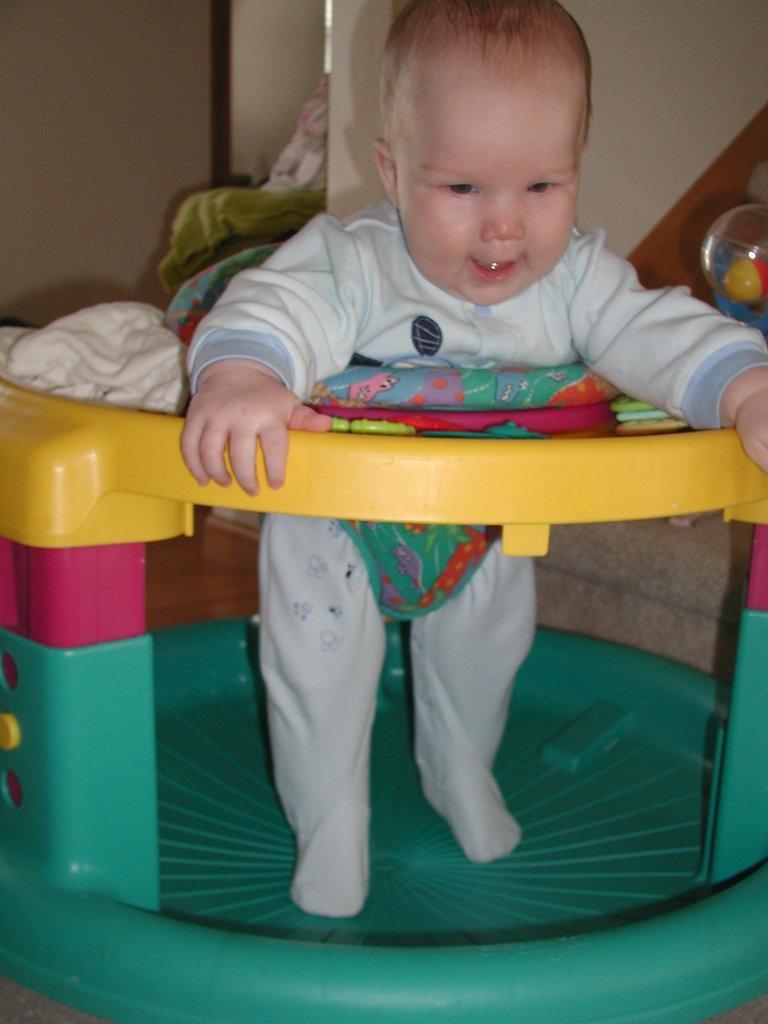In one or two sentences, can you explain what this image depicts? In the image we can see there is an infant standing on the walker. 